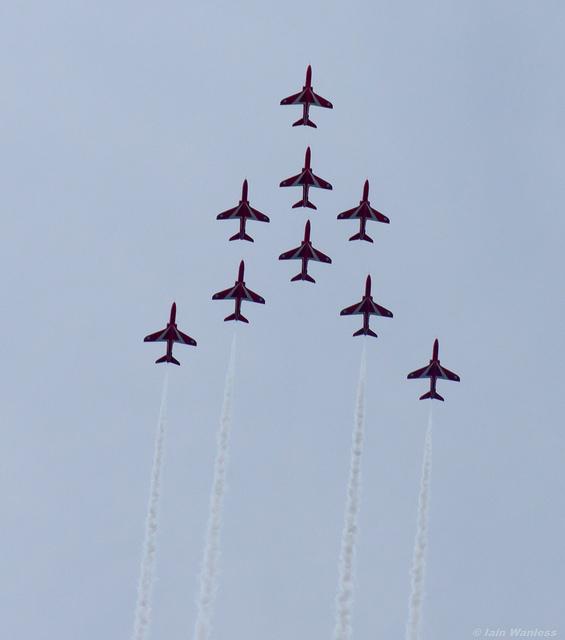Are they jets flying horizontally or vertically?
Quick response, please. Vertically. Are more than half the jets emitting a visible trail?
Concise answer only. No. How many jets are there?
Give a very brief answer. 9. 